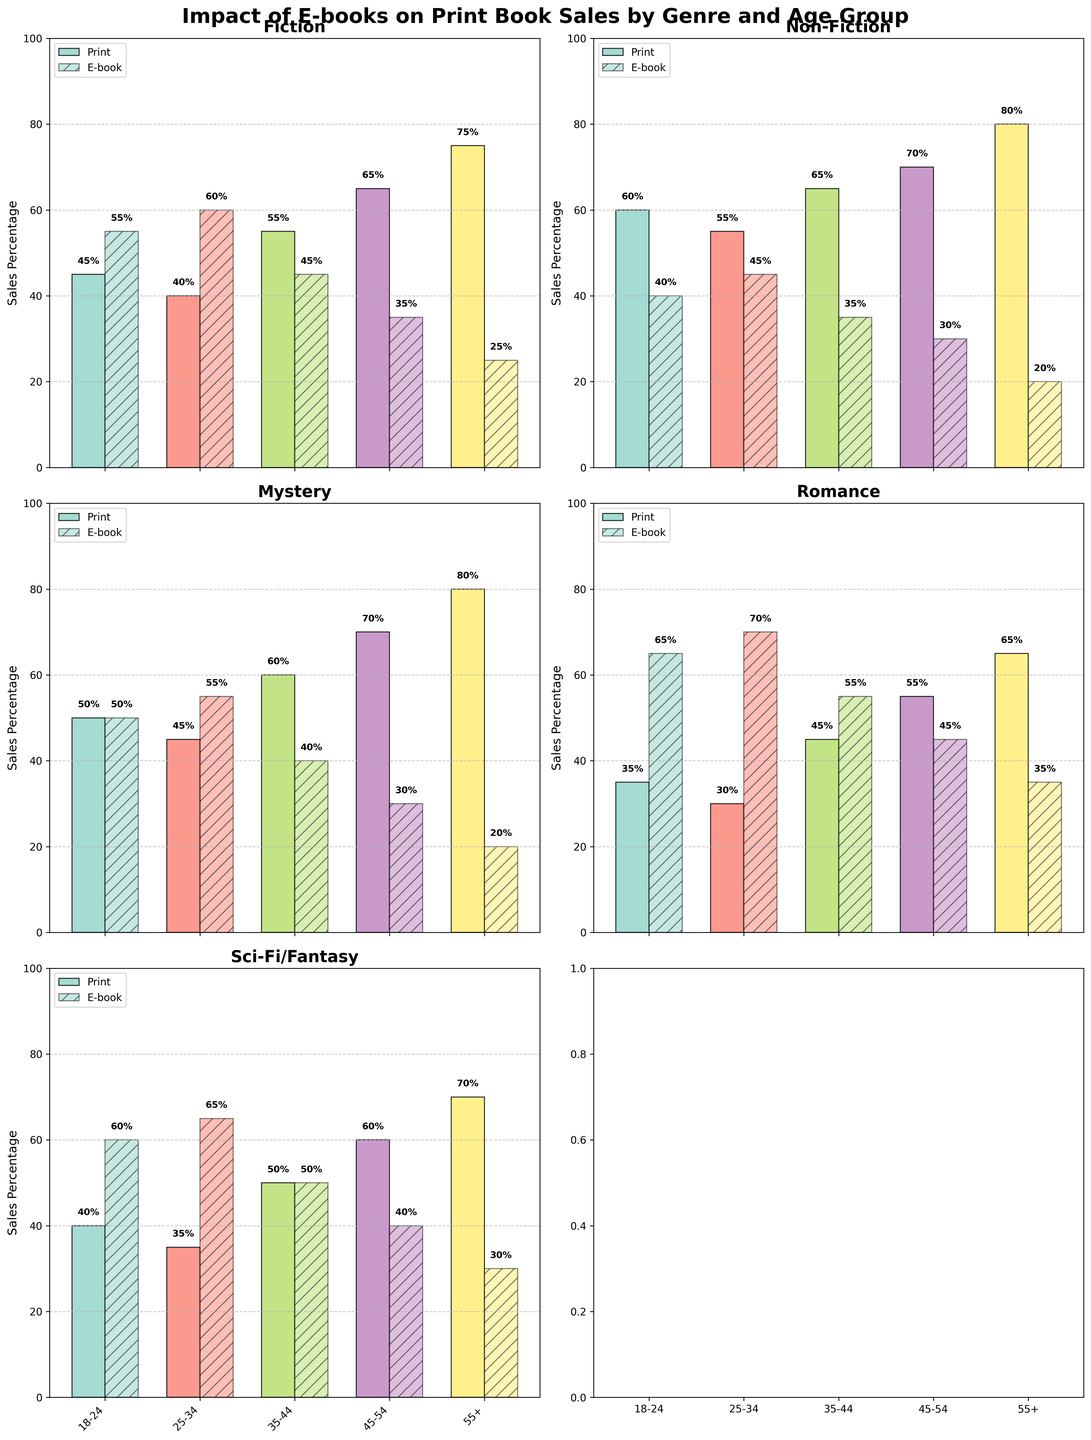What is the title of the figure? The title of the figure is located at the top and is displayed in large, bold font. It typically summarizes the main content or the key message of the figure.
Answer: Impact of E-books on Print Book Sales by Genre and Age Group Which genre has the highest print sales percentage for the age group 55+? Look at the bar heights for the 55+ age group across all subplots. Identify the highest bar for print sales, which is typically represented with stronger transparency (without hatch).
Answer: Non-Fiction What is the age group that contributes the most to e-book sales for Romance? In the subplot for the Romance genre, find the bars labeled for e-book sales (with hatch) and identify the highest bar among all age groups.
Answer: 25-34 In which genre does the 18-24 age group prefer e-books over print books the most? Compare the height difference between the e-book and print sales bars within the 18-24 age group for all genres. The genre where the e-book bar surpasses the print bar by the largest margin indicates the strongest preference for e-books.
Answer: Romance How do print and e-book sales percentages compare for Mystery in the 45-54 age group? In the Mystery subplot, find the bars representing the 45-54 age group and compare the heights of the print and e-book sales bars.
Answer: Print sales: 70%, E-book sales: 30% Which age group shows the most balanced preference between print and e-book sales for Sci-Fi/Fantasy? Check the subplot for Sci-Fi/Fantasy and compare the bar heights for each age group. Balanced preference is indicated when the heights of print and e-book bars are almost equal.
Answer: 35-44 By how much do print book sales for Fiction in the 35-44 age group exceed print book sales for Romance in the same age group? Identify the print sales percentages for Fiction and Romance in the 35-44 age group from their respective subplots. Subtract the Romance percentage from the Fiction percentage.
Answer: 55% - 45% = 10% Which genre and age group combination has the smallest difference between print and e-book sales percentages? Evaluate all subplots and age groups to find the pair where the heights of the print and e-book bars are closest to each other. The smallest numerical difference indicates the answer.
Answer: Sci-Fi/Fantasy, 35-44 What are the print and e-book sales percentages for Non-Fiction in the 25-34 age group? In the Non-Fiction subplot, identify the bars for the 25-34 age group and record the heights of the print and e-book sales bars.
Answer: Print sales: 55%, E-book sales: 45% 